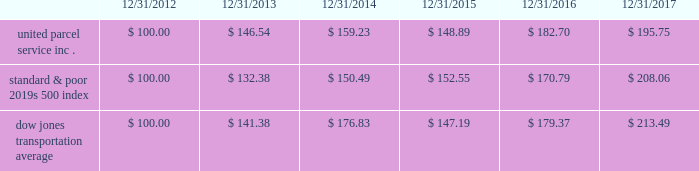Shareowner return performance graph the following performance graph and related information shall not be deemed 201csoliciting material 201d or to be 201cfiled 201d with the sec , nor shall such information be incorporated by reference into any future filing under the securities act of 1933 or securities exchange act of 1934 , each as amended , except to the extent that the company specifically incorporates such information by reference into such filing .
The following graph shows a five-year comparison of cumulative total shareowners 2019 returns for our class b common stock , the standard & poor 2019s 500 index and the dow jones transportation average .
The comparison of the total cumulative return on investment , which is the change in the quarterly stock price plus reinvested dividends for each of the quarterly periods , assumes that $ 100 was invested on december 31 , 2012 in the standard & poor 2019s 500 index , the dow jones transportation average and our class b common stock. .

What was the percentage cumulative total shareowners return for united parcel service inc . for the five years ended 12/31/2017? 
Computations: ((195.75 - 100) / 100)
Answer: 0.9575. 